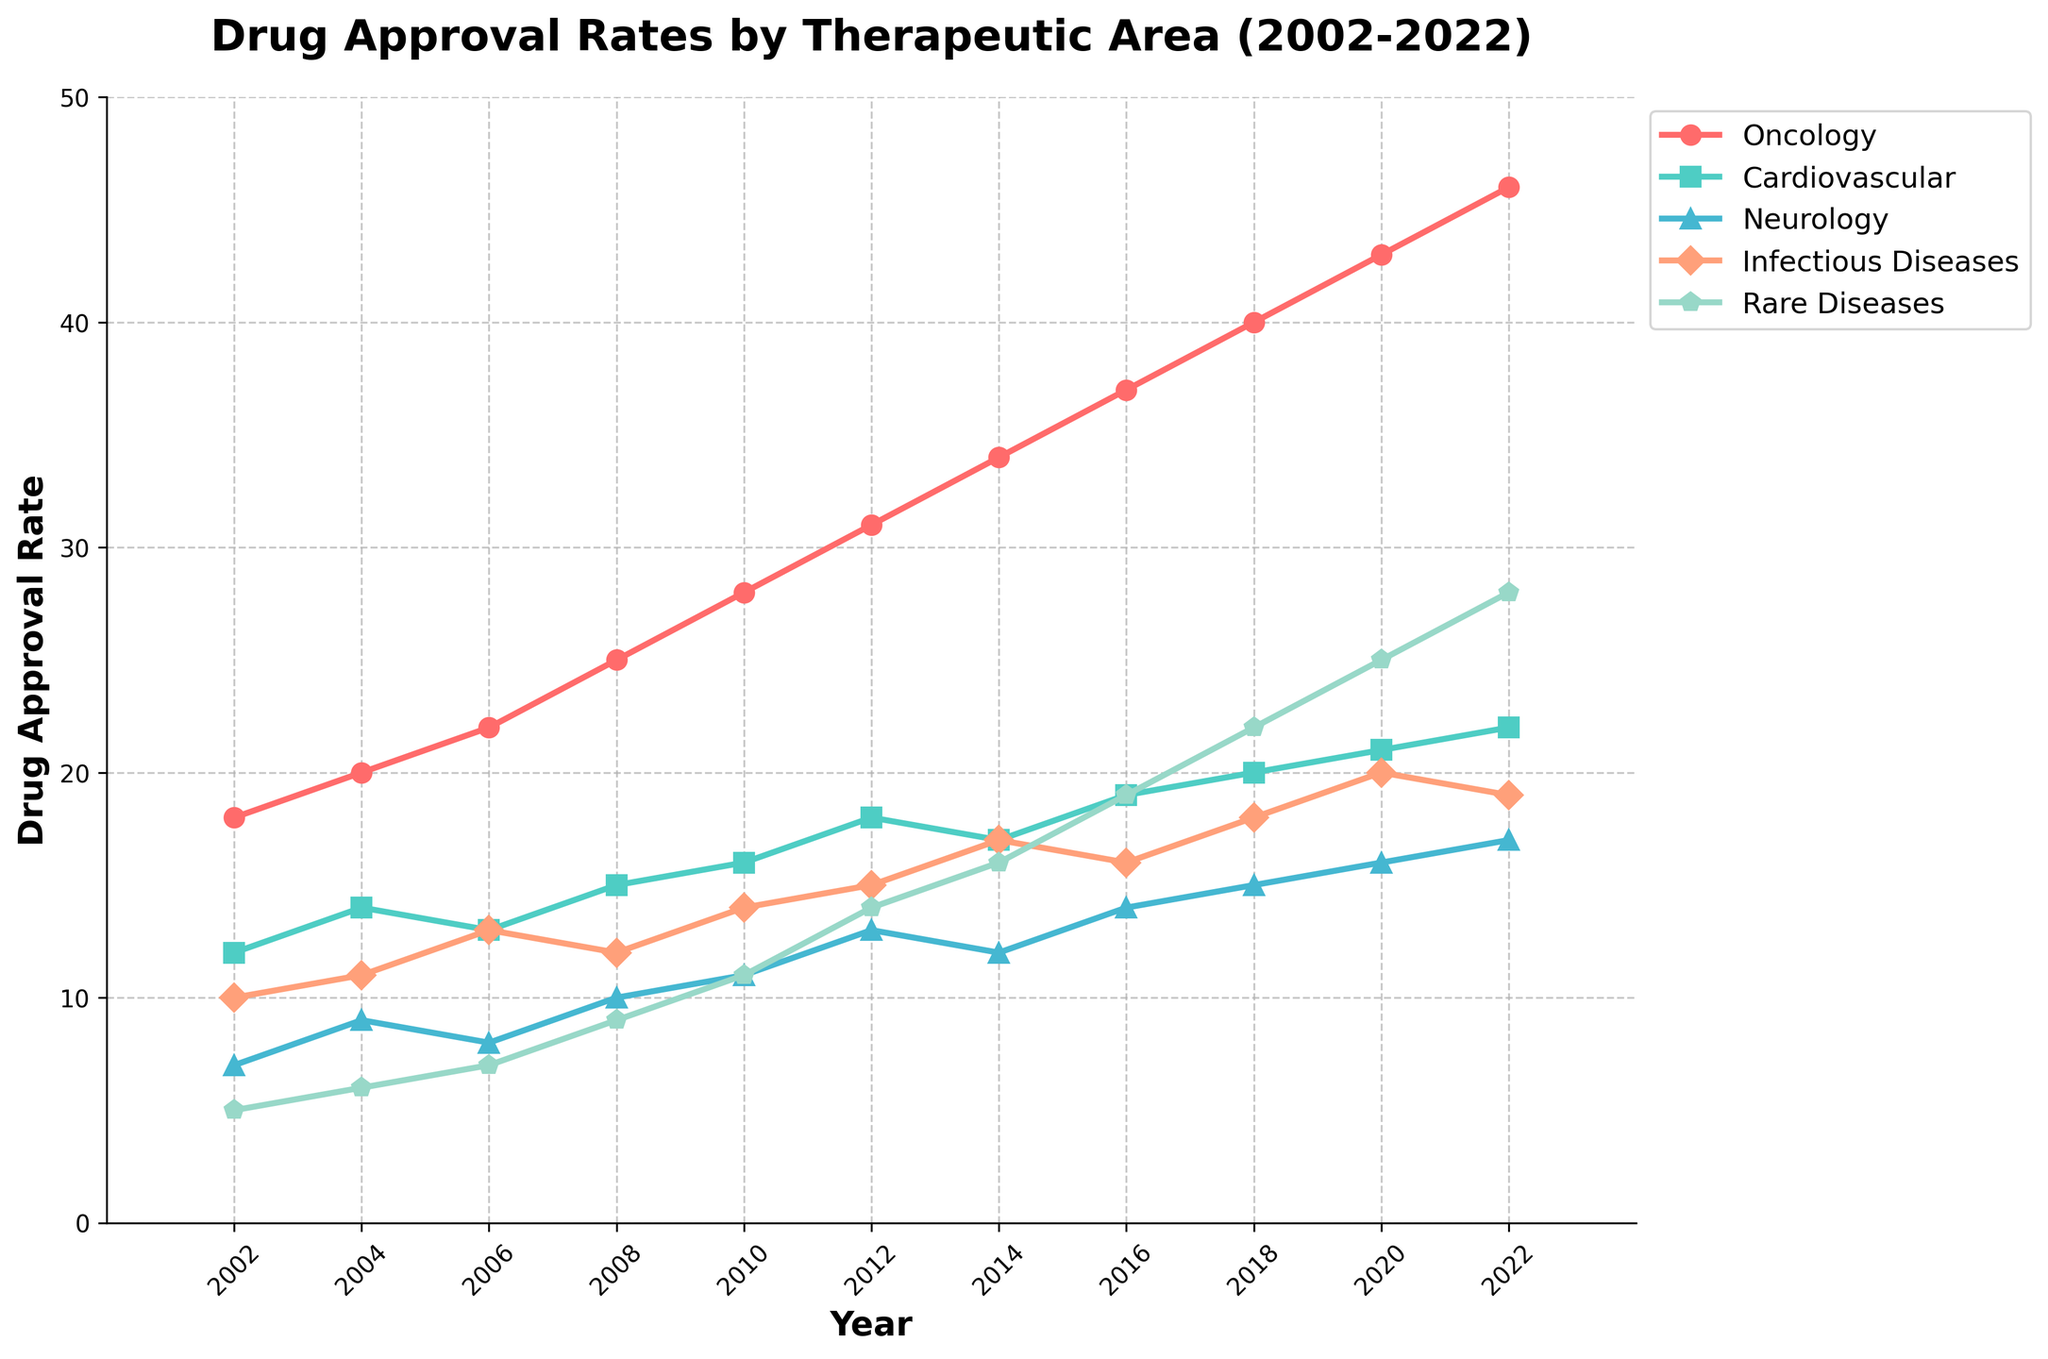What trend do you notice in Oncology's drug approval rate from 2002 to 2022? The line for Oncology shows a consistently upward trend from 2002 to 2022, indicating an increase in the number of drug approvals each year. The drug approval rate for Oncology starts at 18 in 2002 and reaches 46 in 2022.
Answer: Increasing trend In what year did Neurology see a drug approval rate higher than 15 for the first time? By looking at the Neurology line, it first crosses the 15 mark in the year 2018. Before that year, it was consistently below 15.
Answer: 2018 Which therapeutic area had the highest drug approval rate in 2022? In 2022, the lines indicate that Oncology has the highest approval rate at 46, higher than any other therapeutic area represented on the graph.
Answer: Oncology What is the difference in the drug approval rate between Cardiovascular and Infectious Diseases in 2020? In 2020, Cardiovascular has an approval rate of 21, and Infectious Diseases have a rate of 20. The difference is calculated as 21 - 20.
Answer: 1 Looking at the figure, did any therapeutic area have a declining approval rate over the 20-year period? All the therapeutic areas illustrated show either a stable or increasing trend in their approval rates over the period from 2002 to 2022. There is no line that indicates a decline.
Answer: No Which area had a faster growth in the drug approval rate from 2008 to 2022, Oncology or Rare Diseases? Oncology's approval rate grew from 25 in 2008 to 46 in 2022, a difference of 21. Rare Diseases grew from 9 in 2008 to 28 in 2022, a difference of 19. So Oncology had a slightly faster growth over this period.
Answer: Oncology What is the average drug approval rate for Infectious Diseases from 2010 to 2020? The approval rates for Infectious Diseases from 2010 to 2020 are 14, 15, 17, 16, 18, and 20. The sum of these values is (14 + 15 + 17 + 16 + 18 + 20) = 100. The average is 100 / 6.
Answer: 16.67 How does the approval rate for Rare Diseases in 2014 compare to Neurology in that same year? In 2014, Rare Diseases have an approval rate of 16, while Neurology has an approval rate of 12. Rare Diseases have a higher approval rate compared to Neurology in that year.
Answer: Rare Diseases had a higher rate 